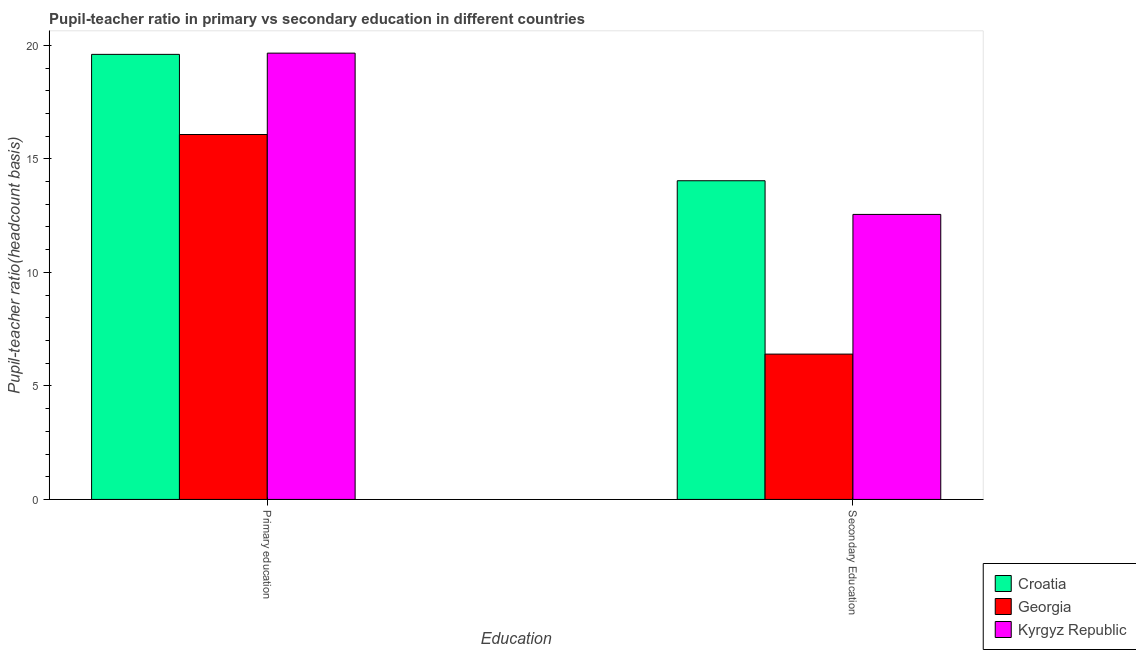How many different coloured bars are there?
Provide a succinct answer. 3. Are the number of bars per tick equal to the number of legend labels?
Keep it short and to the point. Yes. What is the label of the 2nd group of bars from the left?
Your answer should be compact. Secondary Education. What is the pupil teacher ratio on secondary education in Croatia?
Give a very brief answer. 14.04. Across all countries, what is the maximum pupil teacher ratio on secondary education?
Offer a terse response. 14.04. Across all countries, what is the minimum pupil teacher ratio on secondary education?
Your response must be concise. 6.4. In which country was the pupil-teacher ratio in primary education maximum?
Ensure brevity in your answer.  Kyrgyz Republic. In which country was the pupil-teacher ratio in primary education minimum?
Keep it short and to the point. Georgia. What is the total pupil teacher ratio on secondary education in the graph?
Make the answer very short. 32.99. What is the difference between the pupil-teacher ratio in primary education in Croatia and that in Georgia?
Provide a succinct answer. 3.53. What is the difference between the pupil teacher ratio on secondary education in Kyrgyz Republic and the pupil-teacher ratio in primary education in Croatia?
Ensure brevity in your answer.  -7.05. What is the average pupil teacher ratio on secondary education per country?
Provide a succinct answer. 11. What is the difference between the pupil teacher ratio on secondary education and pupil-teacher ratio in primary education in Croatia?
Your answer should be compact. -5.57. What is the ratio of the pupil-teacher ratio in primary education in Croatia to that in Georgia?
Provide a succinct answer. 1.22. Is the pupil teacher ratio on secondary education in Kyrgyz Republic less than that in Croatia?
Provide a succinct answer. Yes. What does the 1st bar from the left in Primary education represents?
Your answer should be very brief. Croatia. What does the 2nd bar from the right in Primary education represents?
Provide a short and direct response. Georgia. Are all the bars in the graph horizontal?
Give a very brief answer. No. How many countries are there in the graph?
Give a very brief answer. 3. Are the values on the major ticks of Y-axis written in scientific E-notation?
Make the answer very short. No. How many legend labels are there?
Make the answer very short. 3. What is the title of the graph?
Your answer should be compact. Pupil-teacher ratio in primary vs secondary education in different countries. What is the label or title of the X-axis?
Offer a very short reply. Education. What is the label or title of the Y-axis?
Provide a short and direct response. Pupil-teacher ratio(headcount basis). What is the Pupil-teacher ratio(headcount basis) in Croatia in Primary education?
Provide a short and direct response. 19.6. What is the Pupil-teacher ratio(headcount basis) of Georgia in Primary education?
Keep it short and to the point. 16.07. What is the Pupil-teacher ratio(headcount basis) in Kyrgyz Republic in Primary education?
Your answer should be very brief. 19.66. What is the Pupil-teacher ratio(headcount basis) in Croatia in Secondary Education?
Offer a terse response. 14.04. What is the Pupil-teacher ratio(headcount basis) in Georgia in Secondary Education?
Make the answer very short. 6.4. What is the Pupil-teacher ratio(headcount basis) of Kyrgyz Republic in Secondary Education?
Your response must be concise. 12.55. Across all Education, what is the maximum Pupil-teacher ratio(headcount basis) of Croatia?
Your answer should be very brief. 19.6. Across all Education, what is the maximum Pupil-teacher ratio(headcount basis) in Georgia?
Ensure brevity in your answer.  16.07. Across all Education, what is the maximum Pupil-teacher ratio(headcount basis) in Kyrgyz Republic?
Your response must be concise. 19.66. Across all Education, what is the minimum Pupil-teacher ratio(headcount basis) in Croatia?
Provide a short and direct response. 14.04. Across all Education, what is the minimum Pupil-teacher ratio(headcount basis) of Georgia?
Provide a succinct answer. 6.4. Across all Education, what is the minimum Pupil-teacher ratio(headcount basis) of Kyrgyz Republic?
Provide a succinct answer. 12.55. What is the total Pupil-teacher ratio(headcount basis) in Croatia in the graph?
Your answer should be compact. 33.64. What is the total Pupil-teacher ratio(headcount basis) in Georgia in the graph?
Your answer should be very brief. 22.47. What is the total Pupil-teacher ratio(headcount basis) in Kyrgyz Republic in the graph?
Provide a short and direct response. 32.21. What is the difference between the Pupil-teacher ratio(headcount basis) of Croatia in Primary education and that in Secondary Education?
Offer a very short reply. 5.57. What is the difference between the Pupil-teacher ratio(headcount basis) in Georgia in Primary education and that in Secondary Education?
Your answer should be very brief. 9.67. What is the difference between the Pupil-teacher ratio(headcount basis) in Kyrgyz Republic in Primary education and that in Secondary Education?
Offer a very short reply. 7.1. What is the difference between the Pupil-teacher ratio(headcount basis) of Croatia in Primary education and the Pupil-teacher ratio(headcount basis) of Georgia in Secondary Education?
Offer a terse response. 13.2. What is the difference between the Pupil-teacher ratio(headcount basis) in Croatia in Primary education and the Pupil-teacher ratio(headcount basis) in Kyrgyz Republic in Secondary Education?
Provide a short and direct response. 7.05. What is the difference between the Pupil-teacher ratio(headcount basis) in Georgia in Primary education and the Pupil-teacher ratio(headcount basis) in Kyrgyz Republic in Secondary Education?
Provide a succinct answer. 3.52. What is the average Pupil-teacher ratio(headcount basis) in Croatia per Education?
Your answer should be compact. 16.82. What is the average Pupil-teacher ratio(headcount basis) of Georgia per Education?
Provide a short and direct response. 11.24. What is the average Pupil-teacher ratio(headcount basis) in Kyrgyz Republic per Education?
Your response must be concise. 16.11. What is the difference between the Pupil-teacher ratio(headcount basis) of Croatia and Pupil-teacher ratio(headcount basis) of Georgia in Primary education?
Provide a succinct answer. 3.53. What is the difference between the Pupil-teacher ratio(headcount basis) of Croatia and Pupil-teacher ratio(headcount basis) of Kyrgyz Republic in Primary education?
Your response must be concise. -0.05. What is the difference between the Pupil-teacher ratio(headcount basis) of Georgia and Pupil-teacher ratio(headcount basis) of Kyrgyz Republic in Primary education?
Make the answer very short. -3.58. What is the difference between the Pupil-teacher ratio(headcount basis) in Croatia and Pupil-teacher ratio(headcount basis) in Georgia in Secondary Education?
Make the answer very short. 7.64. What is the difference between the Pupil-teacher ratio(headcount basis) of Croatia and Pupil-teacher ratio(headcount basis) of Kyrgyz Republic in Secondary Education?
Offer a terse response. 1.48. What is the difference between the Pupil-teacher ratio(headcount basis) in Georgia and Pupil-teacher ratio(headcount basis) in Kyrgyz Republic in Secondary Education?
Make the answer very short. -6.15. What is the ratio of the Pupil-teacher ratio(headcount basis) of Croatia in Primary education to that in Secondary Education?
Your answer should be compact. 1.4. What is the ratio of the Pupil-teacher ratio(headcount basis) in Georgia in Primary education to that in Secondary Education?
Provide a succinct answer. 2.51. What is the ratio of the Pupil-teacher ratio(headcount basis) in Kyrgyz Republic in Primary education to that in Secondary Education?
Your response must be concise. 1.57. What is the difference between the highest and the second highest Pupil-teacher ratio(headcount basis) of Croatia?
Your answer should be compact. 5.57. What is the difference between the highest and the second highest Pupil-teacher ratio(headcount basis) of Georgia?
Keep it short and to the point. 9.67. What is the difference between the highest and the second highest Pupil-teacher ratio(headcount basis) of Kyrgyz Republic?
Provide a short and direct response. 7.1. What is the difference between the highest and the lowest Pupil-teacher ratio(headcount basis) of Croatia?
Provide a succinct answer. 5.57. What is the difference between the highest and the lowest Pupil-teacher ratio(headcount basis) of Georgia?
Provide a succinct answer. 9.67. What is the difference between the highest and the lowest Pupil-teacher ratio(headcount basis) in Kyrgyz Republic?
Make the answer very short. 7.1. 